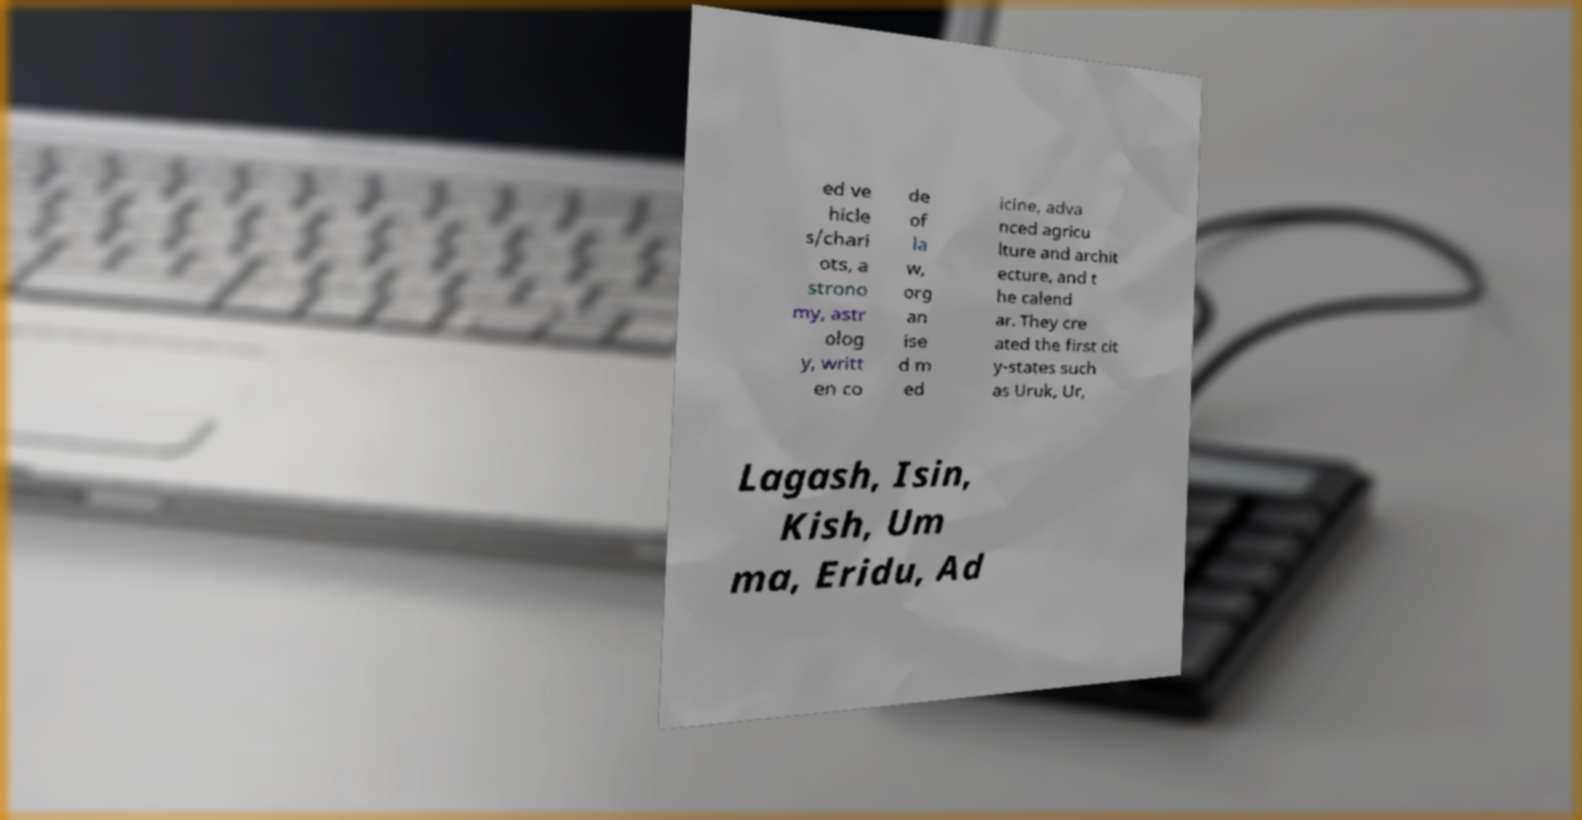What messages or text are displayed in this image? I need them in a readable, typed format. ed ve hicle s/chari ots, a strono my, astr olog y, writt en co de of la w, org an ise d m ed icine, adva nced agricu lture and archit ecture, and t he calend ar. They cre ated the first cit y-states such as Uruk, Ur, Lagash, Isin, Kish, Um ma, Eridu, Ad 